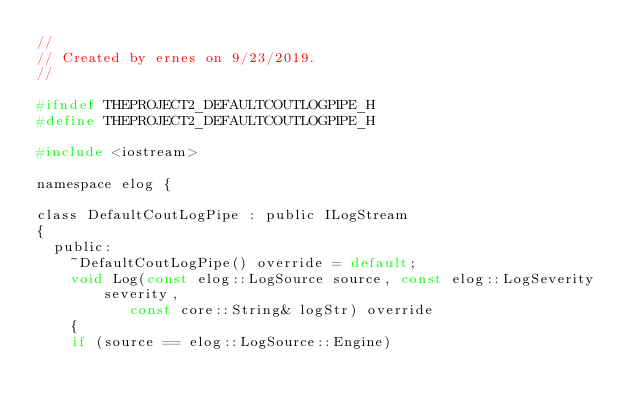Convert code to text. <code><loc_0><loc_0><loc_500><loc_500><_C_>//
// Created by ernes on 9/23/2019.
//

#ifndef THEPROJECT2_DEFAULTCOUTLOGPIPE_H
#define THEPROJECT2_DEFAULTCOUTLOGPIPE_H

#include <iostream>

namespace elog {

class DefaultCoutLogPipe : public ILogStream
{
  public:
    ~DefaultCoutLogPipe() override = default;
    void Log(const elog::LogSource source, const elog::LogSeverity severity,
           const core::String& logStr) override
    {
    if (source == elog::LogSource::Engine)</code> 